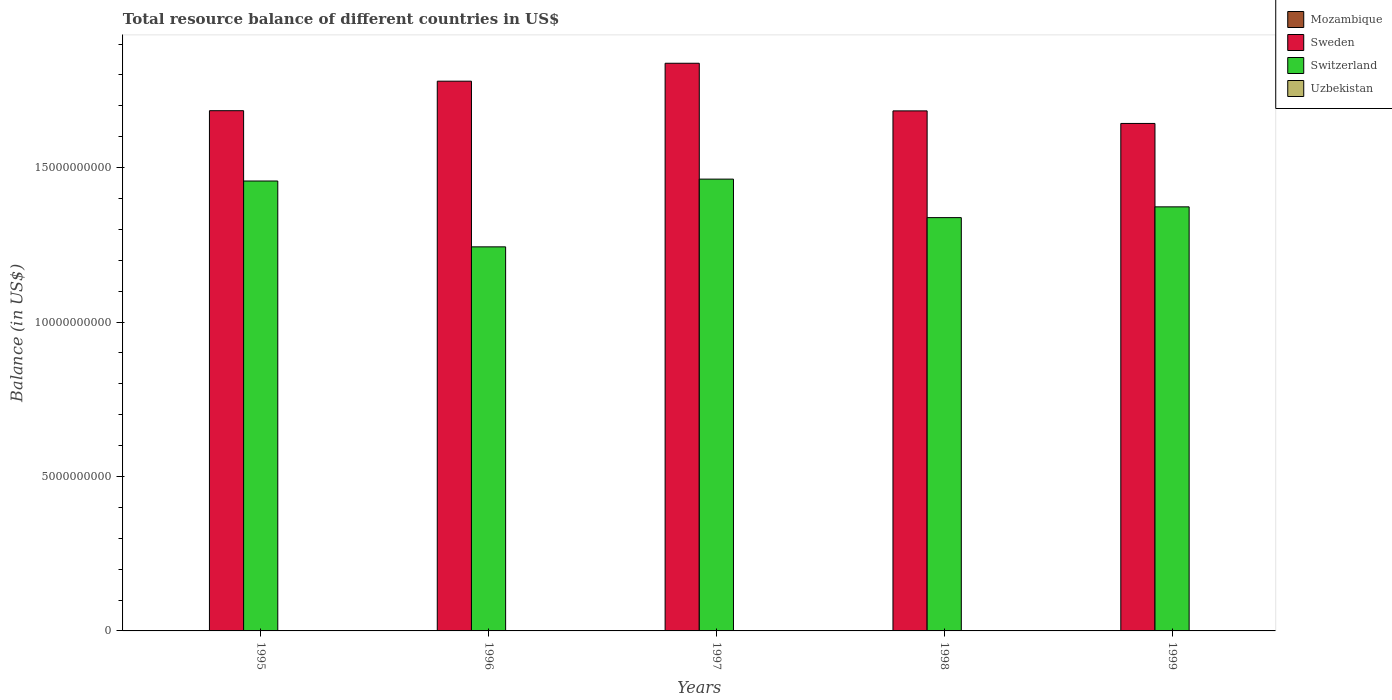How many groups of bars are there?
Keep it short and to the point. 5. Are the number of bars per tick equal to the number of legend labels?
Your response must be concise. No. Are the number of bars on each tick of the X-axis equal?
Give a very brief answer. Yes. How many bars are there on the 3rd tick from the right?
Provide a short and direct response. 2. What is the label of the 1st group of bars from the left?
Your answer should be very brief. 1995. In how many cases, is the number of bars for a given year not equal to the number of legend labels?
Give a very brief answer. 5. What is the total resource balance in Mozambique in 1996?
Your answer should be very brief. 0. Across all years, what is the maximum total resource balance in Switzerland?
Your response must be concise. 1.46e+1. What is the total total resource balance in Uzbekistan in the graph?
Your answer should be compact. 0. What is the difference between the total resource balance in Sweden in 1996 and that in 1999?
Keep it short and to the point. 1.37e+09. What is the difference between the total resource balance in Sweden in 1998 and the total resource balance in Mozambique in 1996?
Provide a succinct answer. 1.68e+1. In the year 1999, what is the difference between the total resource balance in Sweden and total resource balance in Switzerland?
Make the answer very short. 2.70e+09. What is the ratio of the total resource balance in Sweden in 1995 to that in 1999?
Ensure brevity in your answer.  1.03. Is the difference between the total resource balance in Sweden in 1995 and 1998 greater than the difference between the total resource balance in Switzerland in 1995 and 1998?
Offer a terse response. No. What is the difference between the highest and the second highest total resource balance in Switzerland?
Make the answer very short. 6.14e+07. What is the difference between the highest and the lowest total resource balance in Switzerland?
Give a very brief answer. 2.19e+09. In how many years, is the total resource balance in Switzerland greater than the average total resource balance in Switzerland taken over all years?
Your response must be concise. 2. Is it the case that in every year, the sum of the total resource balance in Sweden and total resource balance in Uzbekistan is greater than the sum of total resource balance in Switzerland and total resource balance in Mozambique?
Keep it short and to the point. No. Is it the case that in every year, the sum of the total resource balance in Mozambique and total resource balance in Uzbekistan is greater than the total resource balance in Sweden?
Offer a terse response. No. How many years are there in the graph?
Your response must be concise. 5. What is the difference between two consecutive major ticks on the Y-axis?
Make the answer very short. 5.00e+09. Does the graph contain any zero values?
Provide a succinct answer. Yes. Does the graph contain grids?
Provide a succinct answer. No. Where does the legend appear in the graph?
Give a very brief answer. Top right. How many legend labels are there?
Offer a terse response. 4. How are the legend labels stacked?
Make the answer very short. Vertical. What is the title of the graph?
Provide a succinct answer. Total resource balance of different countries in US$. What is the label or title of the X-axis?
Offer a terse response. Years. What is the label or title of the Y-axis?
Provide a short and direct response. Balance (in US$). What is the Balance (in US$) of Sweden in 1995?
Give a very brief answer. 1.68e+1. What is the Balance (in US$) in Switzerland in 1995?
Make the answer very short. 1.46e+1. What is the Balance (in US$) in Uzbekistan in 1995?
Keep it short and to the point. 0. What is the Balance (in US$) in Mozambique in 1996?
Make the answer very short. 0. What is the Balance (in US$) of Sweden in 1996?
Ensure brevity in your answer.  1.78e+1. What is the Balance (in US$) in Switzerland in 1996?
Provide a short and direct response. 1.24e+1. What is the Balance (in US$) of Mozambique in 1997?
Provide a short and direct response. 0. What is the Balance (in US$) of Sweden in 1997?
Provide a short and direct response. 1.84e+1. What is the Balance (in US$) of Switzerland in 1997?
Your answer should be very brief. 1.46e+1. What is the Balance (in US$) in Uzbekistan in 1997?
Give a very brief answer. 0. What is the Balance (in US$) in Mozambique in 1998?
Make the answer very short. 0. What is the Balance (in US$) of Sweden in 1998?
Provide a short and direct response. 1.68e+1. What is the Balance (in US$) of Switzerland in 1998?
Provide a succinct answer. 1.34e+1. What is the Balance (in US$) in Uzbekistan in 1998?
Ensure brevity in your answer.  0. What is the Balance (in US$) of Sweden in 1999?
Offer a very short reply. 1.64e+1. What is the Balance (in US$) in Switzerland in 1999?
Your answer should be compact. 1.37e+1. What is the Balance (in US$) in Uzbekistan in 1999?
Make the answer very short. 0. Across all years, what is the maximum Balance (in US$) of Sweden?
Offer a very short reply. 1.84e+1. Across all years, what is the maximum Balance (in US$) in Switzerland?
Your response must be concise. 1.46e+1. Across all years, what is the minimum Balance (in US$) of Sweden?
Keep it short and to the point. 1.64e+1. Across all years, what is the minimum Balance (in US$) of Switzerland?
Your response must be concise. 1.24e+1. What is the total Balance (in US$) in Mozambique in the graph?
Ensure brevity in your answer.  0. What is the total Balance (in US$) in Sweden in the graph?
Provide a short and direct response. 8.63e+1. What is the total Balance (in US$) of Switzerland in the graph?
Offer a very short reply. 6.87e+1. What is the total Balance (in US$) of Uzbekistan in the graph?
Offer a terse response. 0. What is the difference between the Balance (in US$) of Sweden in 1995 and that in 1996?
Offer a very short reply. -9.56e+08. What is the difference between the Balance (in US$) of Switzerland in 1995 and that in 1996?
Offer a terse response. 2.13e+09. What is the difference between the Balance (in US$) in Sweden in 1995 and that in 1997?
Your response must be concise. -1.54e+09. What is the difference between the Balance (in US$) of Switzerland in 1995 and that in 1997?
Give a very brief answer. -6.14e+07. What is the difference between the Balance (in US$) of Sweden in 1995 and that in 1998?
Make the answer very short. 5.91e+06. What is the difference between the Balance (in US$) in Switzerland in 1995 and that in 1998?
Ensure brevity in your answer.  1.19e+09. What is the difference between the Balance (in US$) in Sweden in 1995 and that in 1999?
Give a very brief answer. 4.13e+08. What is the difference between the Balance (in US$) in Switzerland in 1995 and that in 1999?
Offer a terse response. 8.36e+08. What is the difference between the Balance (in US$) in Sweden in 1996 and that in 1997?
Offer a terse response. -5.80e+08. What is the difference between the Balance (in US$) of Switzerland in 1996 and that in 1997?
Make the answer very short. -2.19e+09. What is the difference between the Balance (in US$) of Sweden in 1996 and that in 1998?
Your answer should be compact. 9.62e+08. What is the difference between the Balance (in US$) in Switzerland in 1996 and that in 1998?
Your response must be concise. -9.46e+08. What is the difference between the Balance (in US$) in Sweden in 1996 and that in 1999?
Provide a succinct answer. 1.37e+09. What is the difference between the Balance (in US$) of Switzerland in 1996 and that in 1999?
Offer a very short reply. -1.30e+09. What is the difference between the Balance (in US$) of Sweden in 1997 and that in 1998?
Your response must be concise. 1.54e+09. What is the difference between the Balance (in US$) in Switzerland in 1997 and that in 1998?
Provide a short and direct response. 1.25e+09. What is the difference between the Balance (in US$) in Sweden in 1997 and that in 1999?
Your answer should be very brief. 1.95e+09. What is the difference between the Balance (in US$) in Switzerland in 1997 and that in 1999?
Offer a terse response. 8.98e+08. What is the difference between the Balance (in US$) of Sweden in 1998 and that in 1999?
Provide a succinct answer. 4.07e+08. What is the difference between the Balance (in US$) of Switzerland in 1998 and that in 1999?
Your answer should be compact. -3.49e+08. What is the difference between the Balance (in US$) of Sweden in 1995 and the Balance (in US$) of Switzerland in 1996?
Ensure brevity in your answer.  4.41e+09. What is the difference between the Balance (in US$) of Sweden in 1995 and the Balance (in US$) of Switzerland in 1997?
Your answer should be compact. 2.22e+09. What is the difference between the Balance (in US$) in Sweden in 1995 and the Balance (in US$) in Switzerland in 1998?
Make the answer very short. 3.46e+09. What is the difference between the Balance (in US$) in Sweden in 1995 and the Balance (in US$) in Switzerland in 1999?
Ensure brevity in your answer.  3.11e+09. What is the difference between the Balance (in US$) of Sweden in 1996 and the Balance (in US$) of Switzerland in 1997?
Offer a very short reply. 3.17e+09. What is the difference between the Balance (in US$) of Sweden in 1996 and the Balance (in US$) of Switzerland in 1998?
Your answer should be very brief. 4.42e+09. What is the difference between the Balance (in US$) in Sweden in 1996 and the Balance (in US$) in Switzerland in 1999?
Your response must be concise. 4.07e+09. What is the difference between the Balance (in US$) in Sweden in 1997 and the Balance (in US$) in Switzerland in 1998?
Give a very brief answer. 5.00e+09. What is the difference between the Balance (in US$) of Sweden in 1997 and the Balance (in US$) of Switzerland in 1999?
Keep it short and to the point. 4.65e+09. What is the difference between the Balance (in US$) of Sweden in 1998 and the Balance (in US$) of Switzerland in 1999?
Your answer should be very brief. 3.11e+09. What is the average Balance (in US$) in Mozambique per year?
Provide a short and direct response. 0. What is the average Balance (in US$) in Sweden per year?
Make the answer very short. 1.73e+1. What is the average Balance (in US$) in Switzerland per year?
Give a very brief answer. 1.37e+1. In the year 1995, what is the difference between the Balance (in US$) in Sweden and Balance (in US$) in Switzerland?
Your response must be concise. 2.28e+09. In the year 1996, what is the difference between the Balance (in US$) in Sweden and Balance (in US$) in Switzerland?
Keep it short and to the point. 5.36e+09. In the year 1997, what is the difference between the Balance (in US$) in Sweden and Balance (in US$) in Switzerland?
Provide a succinct answer. 3.75e+09. In the year 1998, what is the difference between the Balance (in US$) of Sweden and Balance (in US$) of Switzerland?
Keep it short and to the point. 3.46e+09. In the year 1999, what is the difference between the Balance (in US$) in Sweden and Balance (in US$) in Switzerland?
Your response must be concise. 2.70e+09. What is the ratio of the Balance (in US$) in Sweden in 1995 to that in 1996?
Ensure brevity in your answer.  0.95. What is the ratio of the Balance (in US$) in Switzerland in 1995 to that in 1996?
Your answer should be compact. 1.17. What is the ratio of the Balance (in US$) of Sweden in 1995 to that in 1997?
Offer a terse response. 0.92. What is the ratio of the Balance (in US$) in Sweden in 1995 to that in 1998?
Offer a very short reply. 1. What is the ratio of the Balance (in US$) of Switzerland in 1995 to that in 1998?
Offer a terse response. 1.09. What is the ratio of the Balance (in US$) of Sweden in 1995 to that in 1999?
Ensure brevity in your answer.  1.03. What is the ratio of the Balance (in US$) of Switzerland in 1995 to that in 1999?
Your answer should be compact. 1.06. What is the ratio of the Balance (in US$) in Sweden in 1996 to that in 1997?
Your answer should be very brief. 0.97. What is the ratio of the Balance (in US$) in Switzerland in 1996 to that in 1997?
Make the answer very short. 0.85. What is the ratio of the Balance (in US$) of Sweden in 1996 to that in 1998?
Your answer should be compact. 1.06. What is the ratio of the Balance (in US$) of Switzerland in 1996 to that in 1998?
Your response must be concise. 0.93. What is the ratio of the Balance (in US$) in Switzerland in 1996 to that in 1999?
Your answer should be compact. 0.91. What is the ratio of the Balance (in US$) in Sweden in 1997 to that in 1998?
Your answer should be very brief. 1.09. What is the ratio of the Balance (in US$) of Switzerland in 1997 to that in 1998?
Offer a very short reply. 1.09. What is the ratio of the Balance (in US$) in Sweden in 1997 to that in 1999?
Give a very brief answer. 1.12. What is the ratio of the Balance (in US$) of Switzerland in 1997 to that in 1999?
Your answer should be compact. 1.07. What is the ratio of the Balance (in US$) in Sweden in 1998 to that in 1999?
Give a very brief answer. 1.02. What is the ratio of the Balance (in US$) of Switzerland in 1998 to that in 1999?
Provide a succinct answer. 0.97. What is the difference between the highest and the second highest Balance (in US$) in Sweden?
Give a very brief answer. 5.80e+08. What is the difference between the highest and the second highest Balance (in US$) in Switzerland?
Ensure brevity in your answer.  6.14e+07. What is the difference between the highest and the lowest Balance (in US$) of Sweden?
Your answer should be compact. 1.95e+09. What is the difference between the highest and the lowest Balance (in US$) in Switzerland?
Make the answer very short. 2.19e+09. 